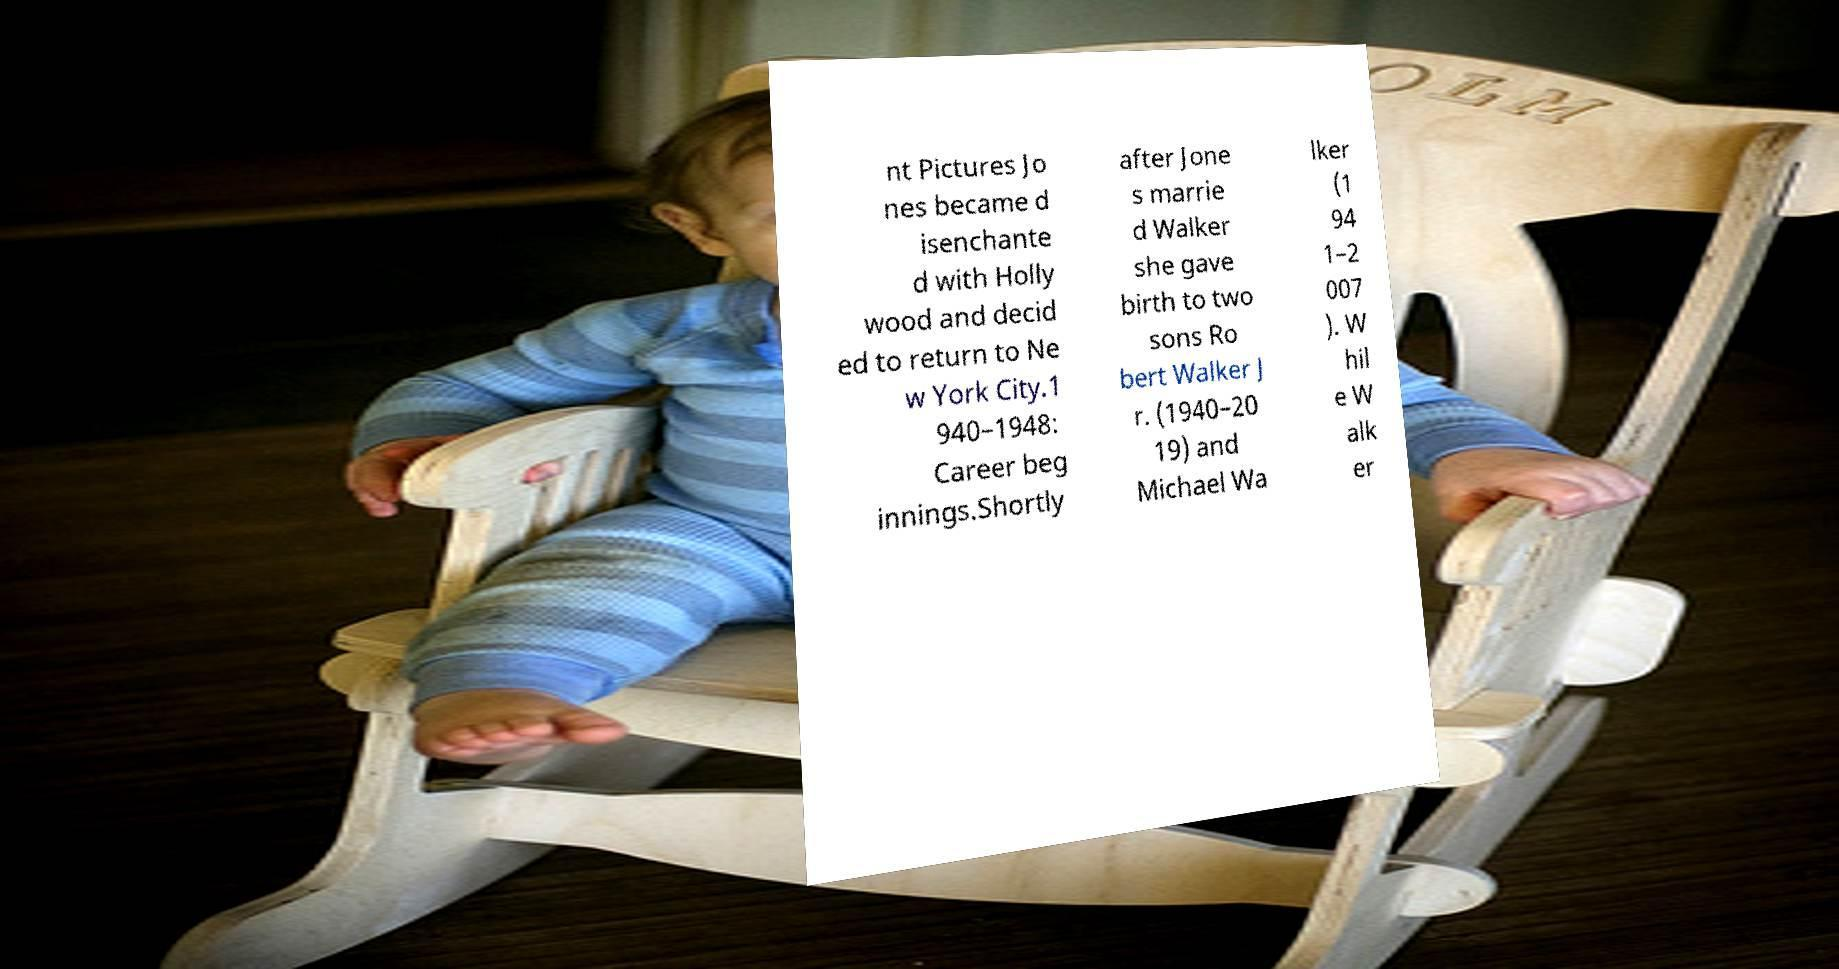Please read and relay the text visible in this image. What does it say? nt Pictures Jo nes became d isenchante d with Holly wood and decid ed to return to Ne w York City.1 940–1948: Career beg innings.Shortly after Jone s marrie d Walker she gave birth to two sons Ro bert Walker J r. (1940–20 19) and Michael Wa lker (1 94 1–2 007 ). W hil e W alk er 